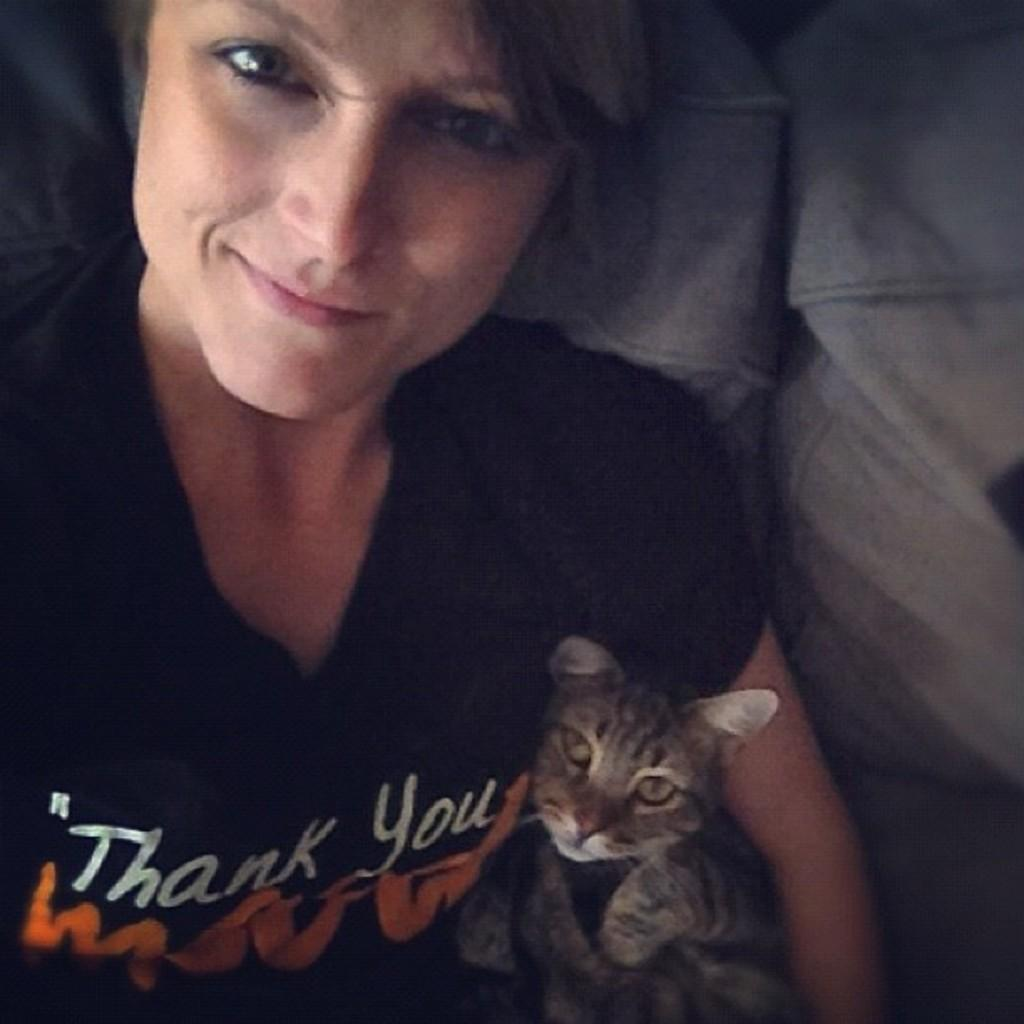Who is present in the image? There is a woman in the image. What is the woman doing in the image? The woman is sitting in a couch. What is the woman holding in the image? The woman is holding a cat. What type of profit can be seen being generated by the plant in the image? There is no plant or profit present in the image. What type of wrench is the woman using to hold the cat in the image? There is no wrench present in the image; the woman is simply holding the cat with her hands. 